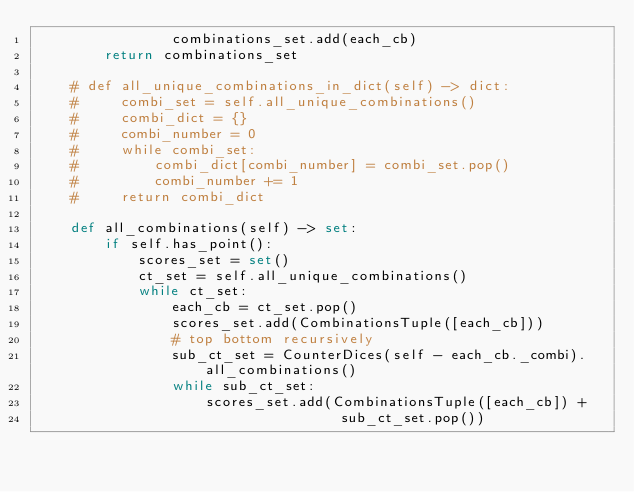<code> <loc_0><loc_0><loc_500><loc_500><_Python_>                combinations_set.add(each_cb)
        return combinations_set

    # def all_unique_combinations_in_dict(self) -> dict:
    #     combi_set = self.all_unique_combinations()
    #     combi_dict = {}
    #     combi_number = 0
    #     while combi_set:
    #         combi_dict[combi_number] = combi_set.pop()
    #         combi_number += 1
    #     return combi_dict

    def all_combinations(self) -> set:
        if self.has_point():
            scores_set = set()
            ct_set = self.all_unique_combinations()
            while ct_set:
                each_cb = ct_set.pop()
                scores_set.add(CombinationsTuple([each_cb]))
                # top bottom recursively
                sub_ct_set = CounterDices(self - each_cb._combi).all_combinations()
                while sub_ct_set:
                    scores_set.add(CombinationsTuple([each_cb]) +
                                    sub_ct_set.pop())</code> 